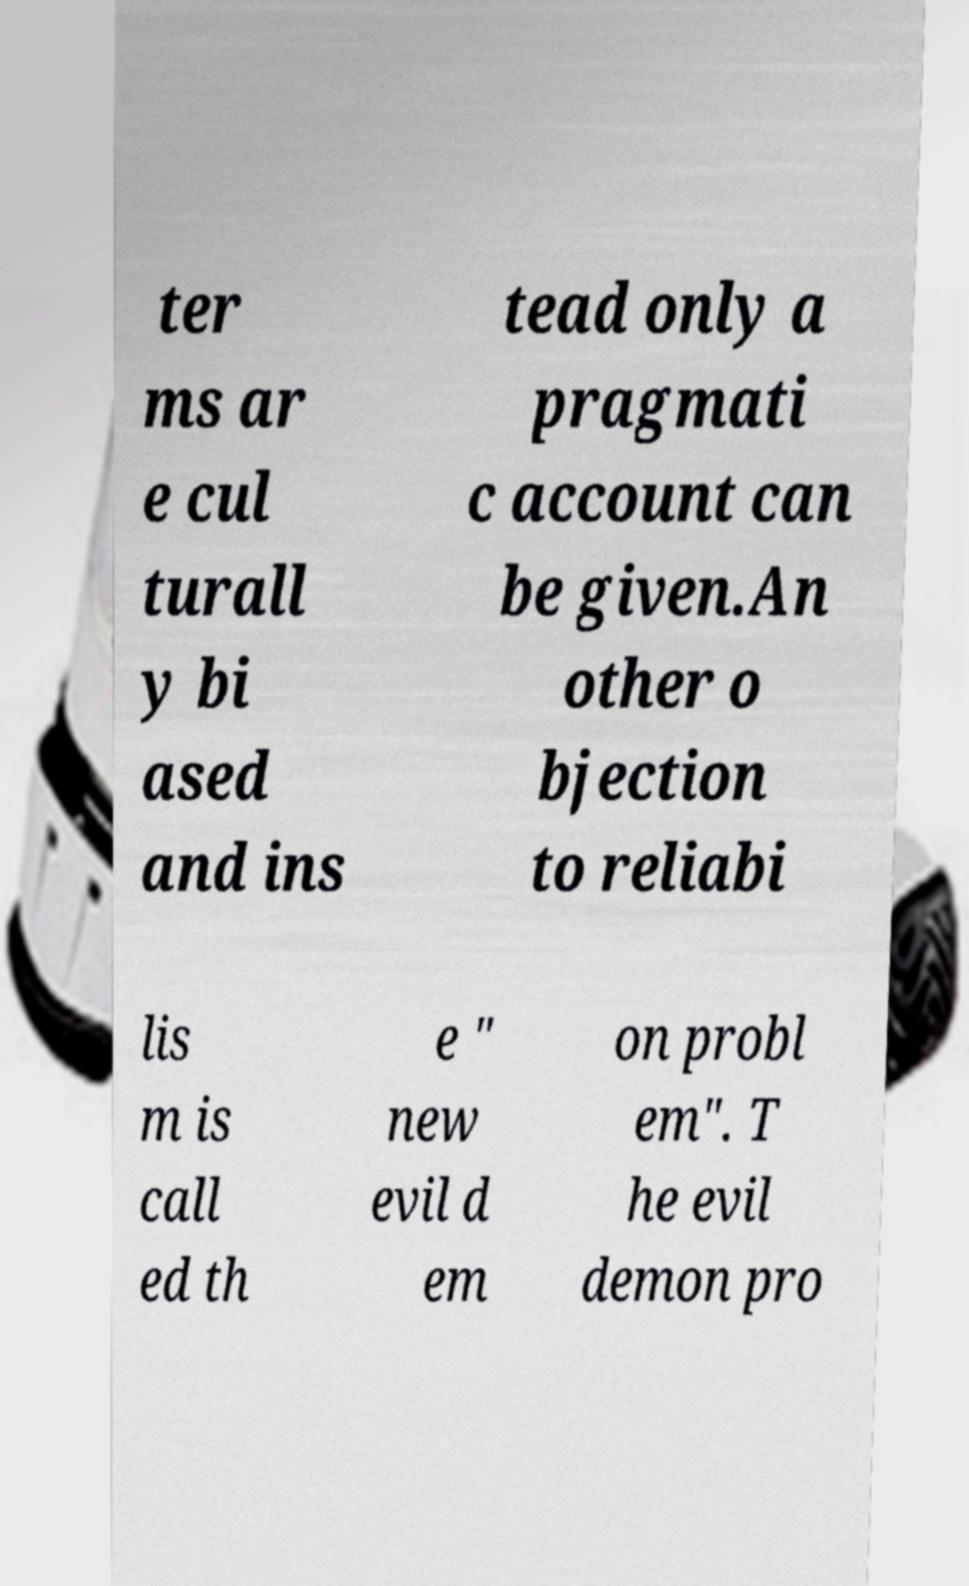Could you assist in decoding the text presented in this image and type it out clearly? ter ms ar e cul turall y bi ased and ins tead only a pragmati c account can be given.An other o bjection to reliabi lis m is call ed th e " new evil d em on probl em". T he evil demon pro 